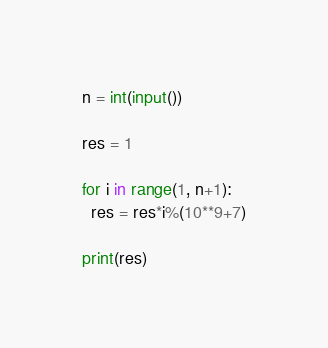<code> <loc_0><loc_0><loc_500><loc_500><_Python_>n = int(input())

res = 1

for i in range(1, n+1):
  res = res*i%(10**9+7)

print(res)</code> 